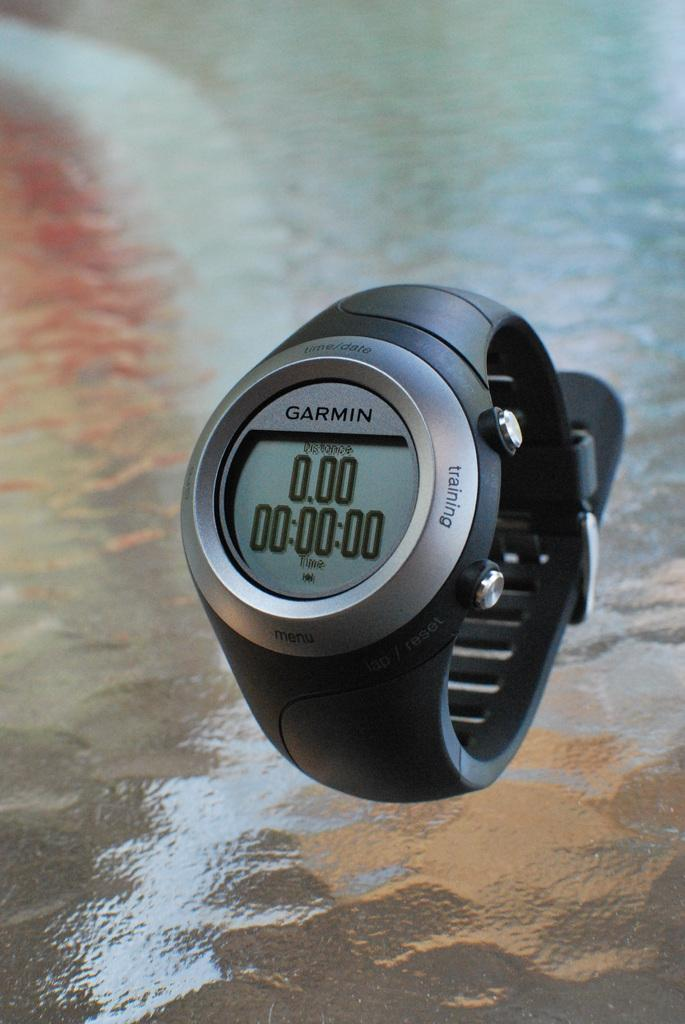<image>
Create a compact narrative representing the image presented. A Garmin training watch has a solid black plastic band. 